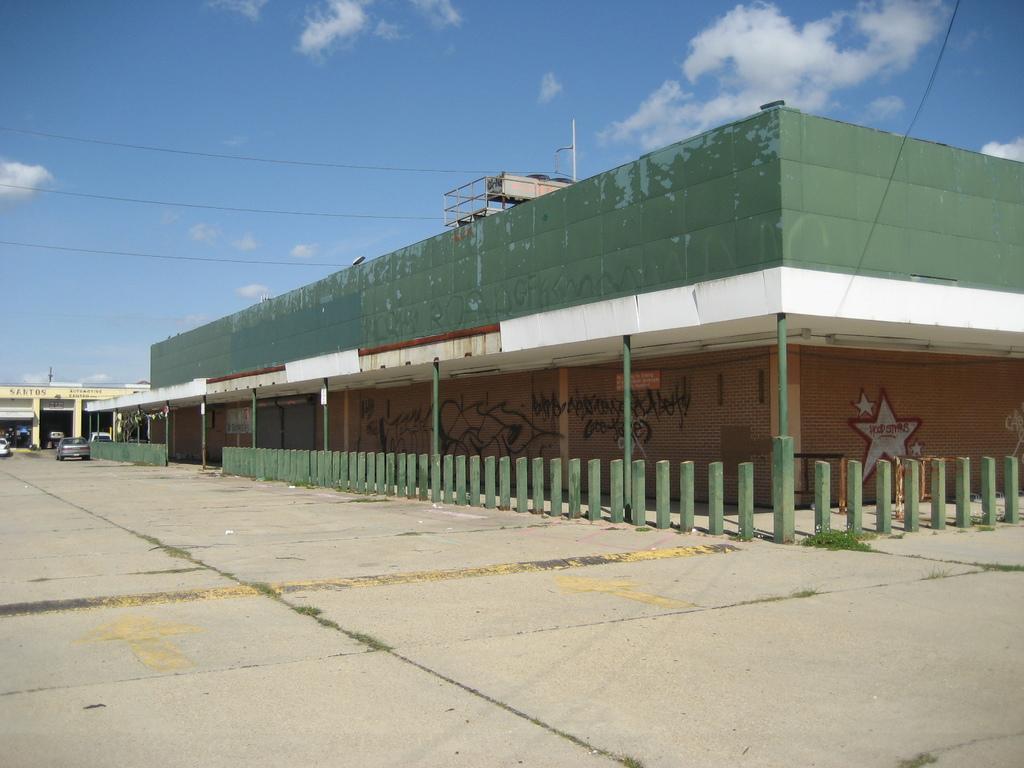How would you summarize this image in a sentence or two? In the foreground I can see a building, fence, shops and vehicles on the road. In the background I can see the blue sky. This image is taken during a day. 